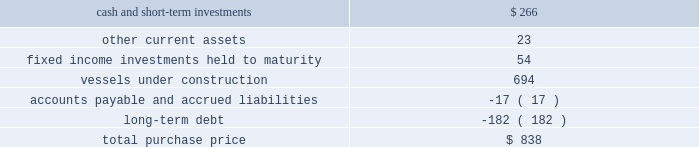Part ii , item 8 fourth quarter of 2007 : 0160 schlumberger sold certain workover rigs for $ 32 million , resulting in a pretax gain of $ 24 million ( $ 17 million after-tax ) which is classified in interest and other income , net in the consolidated statement of income .
Acquisitions acquisition of eastern echo holding plc on december 10 , 2007 , schlumberger completed the acquisition of eastern echo holding plc ( 201ceastern echo 201d ) for $ 838 million in cash .
Eastern echo was a dubai-based marine seismic company that did not have any operations at the time of acquisition , but had signed contracts for the construction of six seismic vessels .
The purchase price has been allocated to the net assets acquired based upon their estimated fair values as follows : ( stated in millions ) .
Other acquisitions schlumberger has made other acquisitions and minority interest investments , none of which were significant on an individual basis , for cash payments , net of cash acquired , of $ 514 million during 2009 , $ 345 million during 2008 , and $ 281 million during 2007 .
Pro forma results pertaining to the above acquisitions are not presented as the impact was not significant .
Drilling fluids joint venture the mi-swaco drilling fluids joint venture is owned 40% ( 40 % ) by schlumberger and 60% ( 60 % ) by smith international , inc .
Schlumberger records income relating to this venture using the equity method of accounting .
The carrying value of schlumberger 2019s investment in the joint venture on december 31 , 2009 and 2008 was $ 1.4 billion and $ 1.3 billion , respectively , and is included within investments in affiliated companies on the consolidated balance sheet .
Schlumberger 2019s equity income from this joint venture was $ 131 million in 2009 , $ 210 million in 2008 and $ 178 million in 2007 .
Schlumberger received cash distributions from the joint venture of $ 106 million in 2009 , $ 57 million in 2008 and $ 46 million in 2007 .
The joint venture agreement contains a provision under which either party to the joint venture may offer to sell its entire interest in the venture to the other party at a cash purchase price per percentage interest specified in an offer notice .
If the offer to sell is not accepted , the offering party will be obligated to purchase the entire interest of the other party at the same price per percentage interest as the prices specified in the offer notice. .
What was the debt to asset ratio in the eastern echo holding plc acquisition? 
Rationale: the composition of the acquisition of eastern echo holding plc was made of $ 0.19 of debt for every $ 1 of assets
Computations: ((182 + 17) / (838 + (182 + 17)))
Answer: 0.1919. 